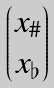<formula> <loc_0><loc_0><loc_500><loc_500>\begin{pmatrix} x _ { \# } \\ x _ { \flat } \end{pmatrix}</formula> 